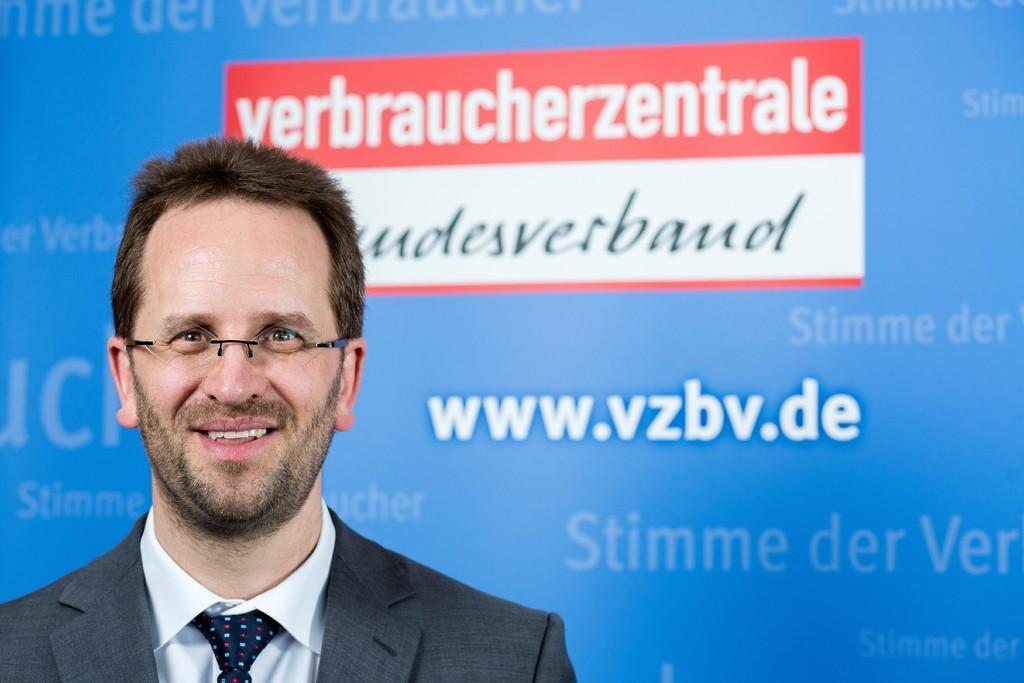What is located on the left side of the image? There is a man standing on the left side of the image. What is the man wearing in the image? The man is wearing a coat and a tie. What can be seen in the background of the image? There is a screen visible in the background of the image. What type of jam is the man spreading on the base in the image? There is no jam or base present in the image; it features a man standing on the left side, wearing a coat and a tie, with a screen visible in the background. 